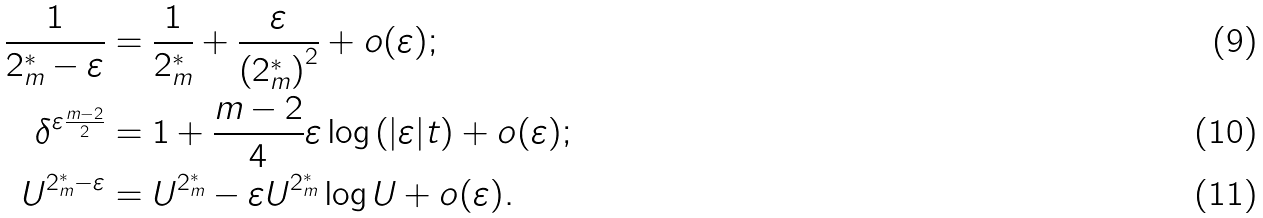<formula> <loc_0><loc_0><loc_500><loc_500>\frac { 1 } { 2 _ { m } ^ { * } - \varepsilon } & = \frac { 1 } { 2 _ { m } ^ { * } } + \frac { \varepsilon } { \left ( 2 _ { m } ^ { * } \right ) ^ { 2 } } + o ( \varepsilon ) ; \\ \delta ^ { \varepsilon \frac { m - 2 } { 2 } } & = 1 + \frac { m - 2 } { 4 } \varepsilon \log \left ( | \varepsilon | t \right ) + o ( \varepsilon ) ; \\ U ^ { 2 _ { m } ^ { * } - \varepsilon } & = U ^ { 2 _ { m } ^ { * } } - \varepsilon U ^ { 2 _ { m } ^ { * } } \log U + o ( \varepsilon ) .</formula> 